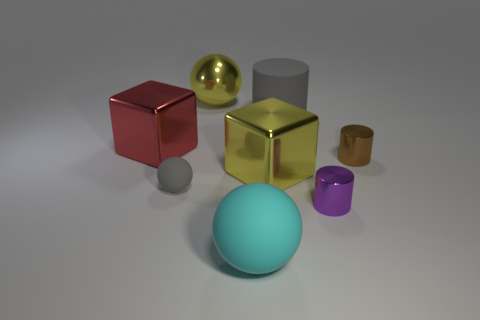Can you describe the lighting and shadows in the image? Certainly. The scene is lit from above and to the right, as indicated by the shadows cast on the floor towards the lower left. The light is diffused, softening the edges of the shadows. Each object's surface also reflects and diffuses light to different degrees, which hints at the material's texture; the shiny objects have brighter highlights and defined reflections, while the matte surfaces, like the blue sphere in the foreground, have more evenly scattered light and softer shadows. 